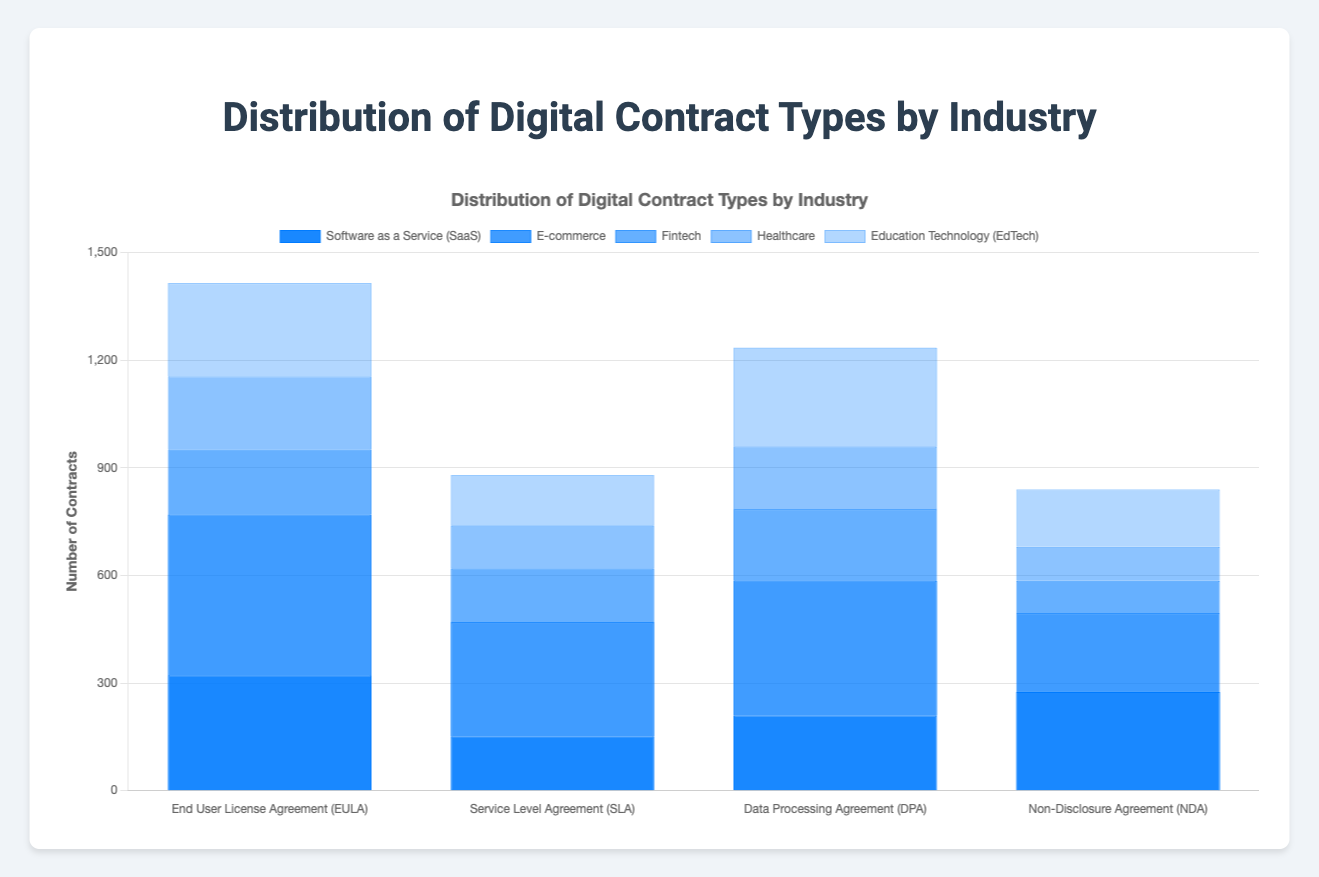What is the total number of "End User License Agreement (EULA)" contracts across all industries? To find the total number of "End User License Agreement (EULA)" contracts, sum the counts for this contract type in the listed industries. Here, only "Software as a Service (SaaS)" has EULA contracts with a count of 320.
Answer: 320 Which industry has the highest number of "Privacy Policy" contracts? Compare the number of "Privacy Policy" contracts across industries. E-commerce has 375, while Education Technology (EdTech) has 275 contracts. Therefore, E-commerce has the highest number.
Answer: E-commerce How many more "Terms of Service (ToS)" contracts are there compared to "Business Associate Agreement (BAA)" contracts? Subtract the number of "Business Associate Agreement (BAA)" contracts from "Terms of Service (ToS)" contracts. "Terms of Service (ToS)" has 450, and "Business Associate Agreement (BAA)" has 175. So, 450 - 175 = 275.
Answer: 275 What is the industry with the least number of "Service Level Agreement (SLA)" contracts, and how many are there? Compare the number of "Service Level Agreement (SLA)" contracts across all industries. Only SaaS has SLA contracts, with a count of 150.
Answer: SaaS, 150 How does the number of "Non-Disclosure Agreement (NDA)" contracts in SaaS compare to "Data Sharing Agreement" contracts in Fintech? Compare the counts: SaaS has 275 "Non-Disclosure Agreement (NDA)" contracts, while Fintech has 150 "Data Sharing Agreement" contracts. 275 is greater than 150.
Answer: NDA in SaaS is greater What's the total number of contracts in the Healthcare industry? Sum the counts of all contract types in the Healthcare industry: 205 (Patient Consent Forms) + 120 (Provider Agreement) + 175 (BAA) + 95 (DUA) = 595.
Answer: 595 What is the average number of "Service Agreement" contracts in the listed industries? The total number of "Service Agreement" contracts is 200 in Fintech. Since it's the only industry with this contract type, the average is 200/1 = 200.
Answer: 200 Which two industries have the closest counts for any specific contract type, and what are those counts? Compare counts for each contract type across industries to find the closest pair. Comparing "End User License Agreement (EULA)" in SaaS (320) and "Return and Refund Policy" in E-commerce (320), both have the same count of 320.
Answer: SaaS and E-commerce, 320 